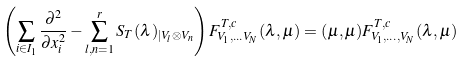Convert formula to latex. <formula><loc_0><loc_0><loc_500><loc_500>\left ( \sum _ { i \in I _ { 1 } } \frac { \partial ^ { 2 } } { \partial x _ { i } ^ { 2 } } - \sum _ { l , n = 1 } ^ { r } S _ { T } ( \lambda ) _ { | V _ { l } \otimes V _ { n } } \right ) F ^ { T , c } _ { V _ { 1 } , \dots V _ { N } } ( \lambda , \mu ) = ( \mu , \mu ) F ^ { T , c } _ { V _ { 1 } , \dots , V _ { N } } ( \lambda , \mu )</formula> 